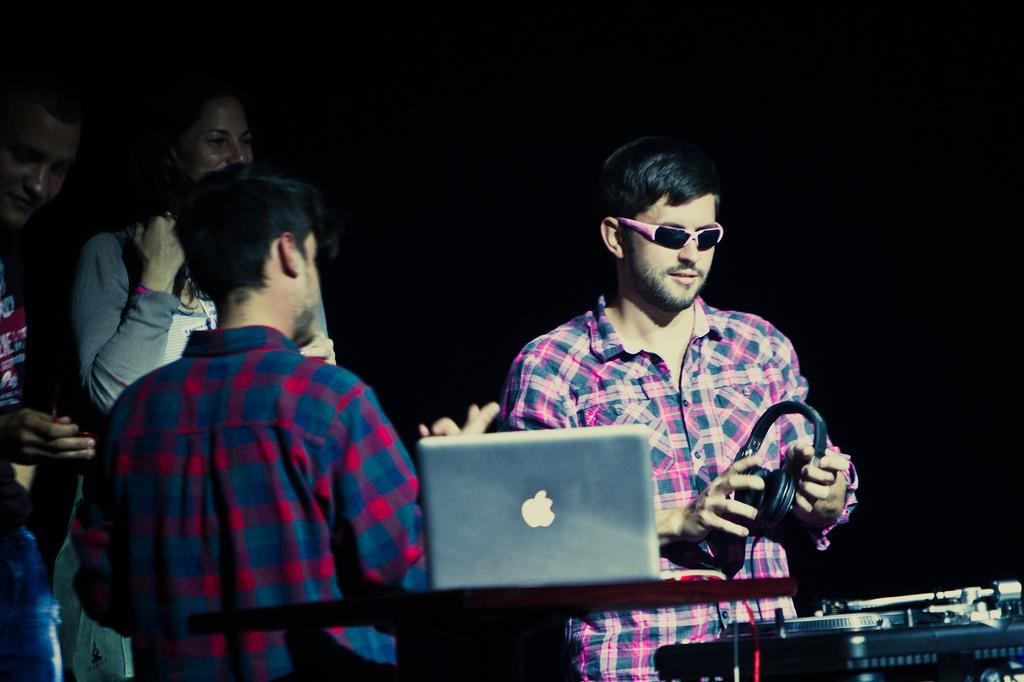What is the man in the image holding? The man is holding a headset. What electronic device can be seen on a table in the image? There is a laptop on a table in the image. What type of equipment is present in the image for playing music? There is a DJ system in the image. How many people are standing in the image? There are three persons standing in the image. What is the color of the background in the image? The background of the image is dark. What type of spring is visible in the image? There is no spring present in the image. Is there an umbrella being used by any of the persons in the image? No, there is no umbrella present in the image. 